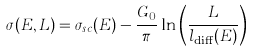<formula> <loc_0><loc_0><loc_500><loc_500>\sigma ( E , L ) = \sigma _ { s c } ( E ) - \frac { G _ { 0 } } { \pi } \ln \left ( \frac { L } { l _ { \text {diff} } ( E ) } \right )</formula> 